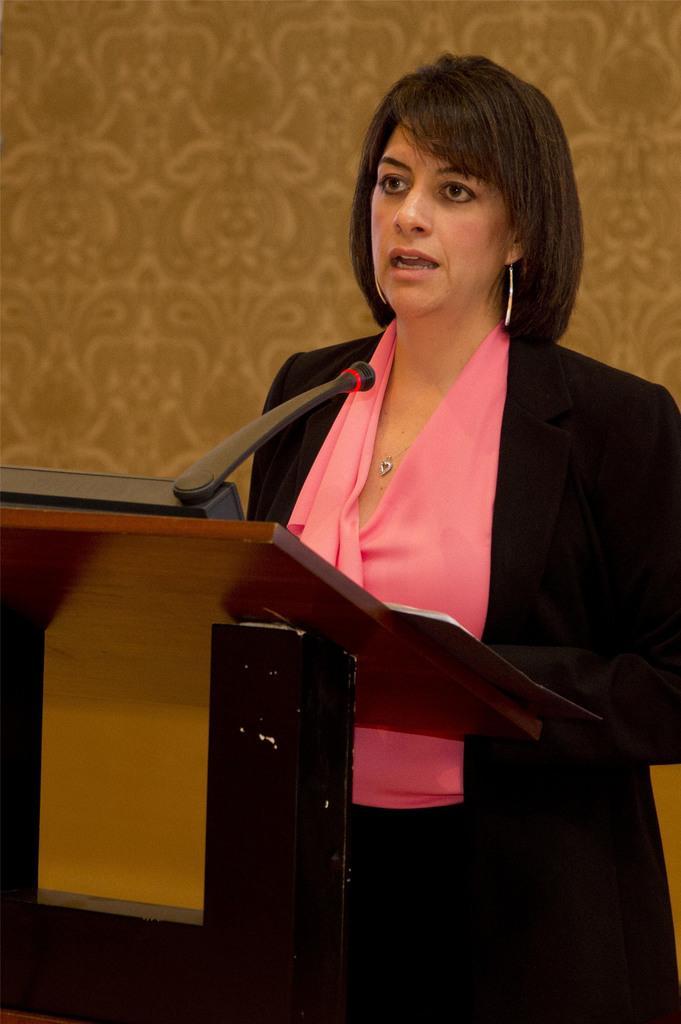Can you describe this image briefly? In this picture I see a podium in front on which there is a mic and in front of the podium I see a woman who is standing and I see that she is wearing pink and black dress and in the background I see the wall. 